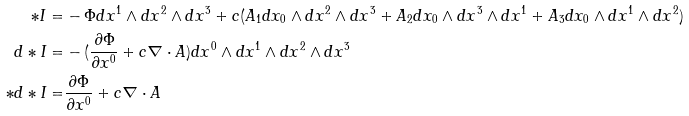<formula> <loc_0><loc_0><loc_500><loc_500>* I = & - \Phi d x ^ { 1 } \wedge d x ^ { 2 } \wedge d x ^ { 3 } + c ( A _ { 1 } d x _ { 0 } \wedge d x ^ { 2 } \wedge d x ^ { 3 } + A _ { 2 } d x _ { 0 } \wedge d x ^ { 3 } \wedge d x ^ { 1 } + A _ { 3 } d x _ { 0 } \wedge d x ^ { 1 } \wedge d x ^ { 2 } ) \\ d * I = & - ( \frac { \partial \Phi } { \partial x ^ { 0 } } + c \nabla \cdot A ) d x ^ { 0 } \wedge d x ^ { 1 } \wedge d x ^ { 2 } \wedge d x ^ { 3 } \\ * d * I = & \frac { \partial \Phi } { \partial x ^ { 0 } } + c \nabla \cdot A</formula> 